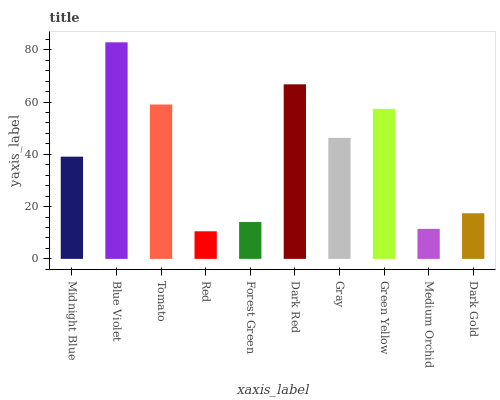Is Red the minimum?
Answer yes or no. Yes. Is Blue Violet the maximum?
Answer yes or no. Yes. Is Tomato the minimum?
Answer yes or no. No. Is Tomato the maximum?
Answer yes or no. No. Is Blue Violet greater than Tomato?
Answer yes or no. Yes. Is Tomato less than Blue Violet?
Answer yes or no. Yes. Is Tomato greater than Blue Violet?
Answer yes or no. No. Is Blue Violet less than Tomato?
Answer yes or no. No. Is Gray the high median?
Answer yes or no. Yes. Is Midnight Blue the low median?
Answer yes or no. Yes. Is Green Yellow the high median?
Answer yes or no. No. Is Green Yellow the low median?
Answer yes or no. No. 